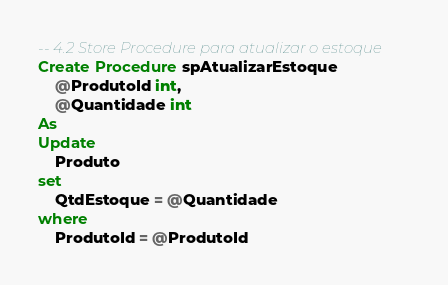<code> <loc_0><loc_0><loc_500><loc_500><_SQL_>-- 4.2 Store Procedure para atualizar o estoque
Create Procedure spAtualizarEstoque
	@ProdutoId int,
	@Quantidade int
As
Update
	Produto
set
	QtdEstoque = @Quantidade
where
	ProdutoId = @ProdutoId</code> 